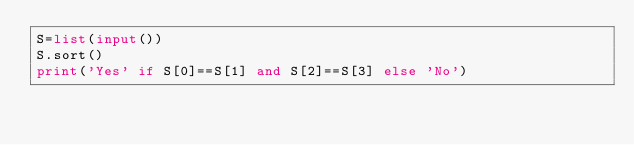Convert code to text. <code><loc_0><loc_0><loc_500><loc_500><_Python_>S=list(input())
S.sort()
print('Yes' if S[0]==S[1] and S[2]==S[3] else 'No')</code> 